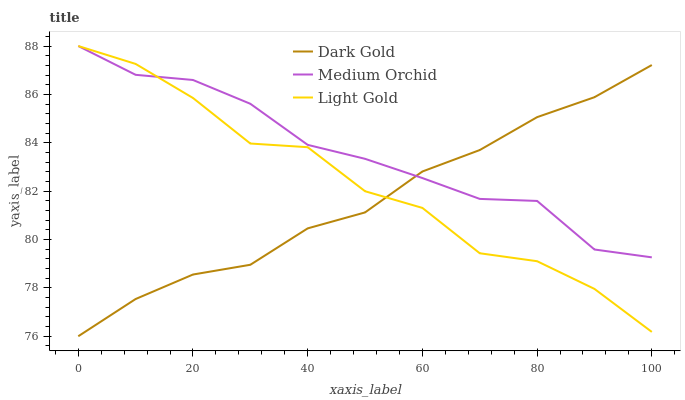Does Dark Gold have the minimum area under the curve?
Answer yes or no. Yes. Does Medium Orchid have the maximum area under the curve?
Answer yes or no. Yes. Does Light Gold have the minimum area under the curve?
Answer yes or no. No. Does Light Gold have the maximum area under the curve?
Answer yes or no. No. Is Dark Gold the smoothest?
Answer yes or no. Yes. Is Light Gold the roughest?
Answer yes or no. Yes. Is Light Gold the smoothest?
Answer yes or no. No. Is Dark Gold the roughest?
Answer yes or no. No. Does Dark Gold have the lowest value?
Answer yes or no. Yes. Does Light Gold have the lowest value?
Answer yes or no. No. Does Light Gold have the highest value?
Answer yes or no. Yes. Does Dark Gold have the highest value?
Answer yes or no. No. Does Light Gold intersect Dark Gold?
Answer yes or no. Yes. Is Light Gold less than Dark Gold?
Answer yes or no. No. Is Light Gold greater than Dark Gold?
Answer yes or no. No. 